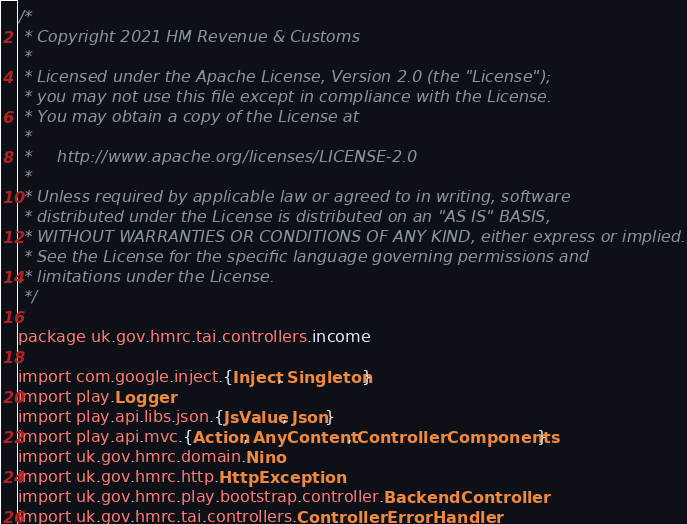Convert code to text. <code><loc_0><loc_0><loc_500><loc_500><_Scala_>/*
 * Copyright 2021 HM Revenue & Customs
 *
 * Licensed under the Apache License, Version 2.0 (the "License");
 * you may not use this file except in compliance with the License.
 * You may obtain a copy of the License at
 *
 *     http://www.apache.org/licenses/LICENSE-2.0
 *
 * Unless required by applicable law or agreed to in writing, software
 * distributed under the License is distributed on an "AS IS" BASIS,
 * WITHOUT WARRANTIES OR CONDITIONS OF ANY KIND, either express or implied.
 * See the License for the specific language governing permissions and
 * limitations under the License.
 */

package uk.gov.hmrc.tai.controllers.income

import com.google.inject.{Inject, Singleton}
import play.Logger
import play.api.libs.json.{JsValue, Json}
import play.api.mvc.{Action, AnyContent, ControllerComponents}
import uk.gov.hmrc.domain.Nino
import uk.gov.hmrc.http.HttpException
import uk.gov.hmrc.play.bootstrap.controller.BackendController
import uk.gov.hmrc.tai.controllers.ControllerErrorHandler</code> 